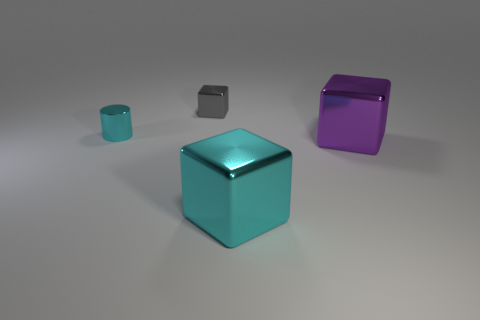Subtract all big metallic blocks. How many blocks are left? 1 Add 2 cylinders. How many objects exist? 6 Subtract all blocks. How many objects are left? 1 Add 2 big yellow rubber things. How many big yellow rubber things exist? 2 Subtract 0 blue balls. How many objects are left? 4 Subtract all big cyan cubes. Subtract all cubes. How many objects are left? 0 Add 2 tiny gray cubes. How many tiny gray cubes are left? 3 